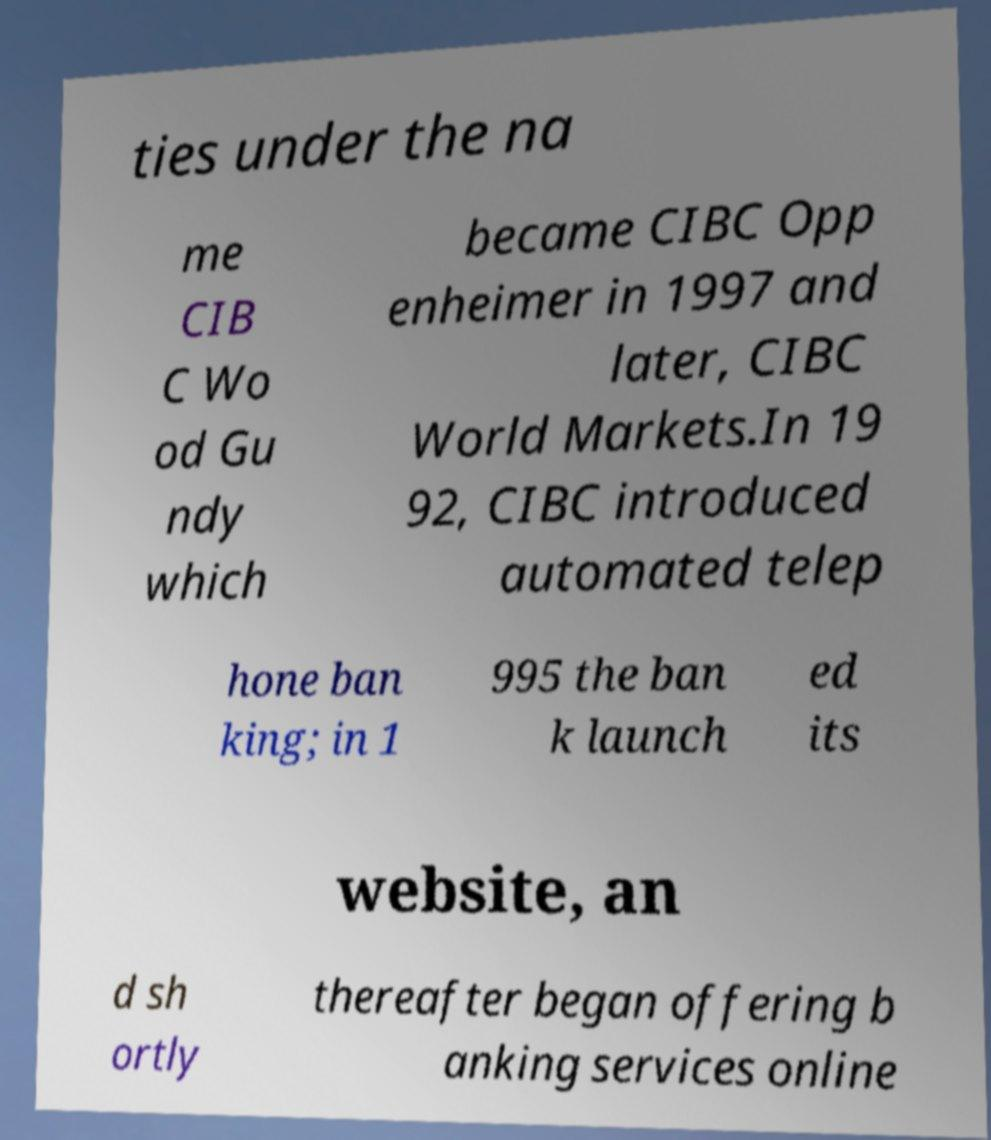Can you accurately transcribe the text from the provided image for me? ties under the na me CIB C Wo od Gu ndy which became CIBC Opp enheimer in 1997 and later, CIBC World Markets.In 19 92, CIBC introduced automated telep hone ban king; in 1 995 the ban k launch ed its website, an d sh ortly thereafter began offering b anking services online 